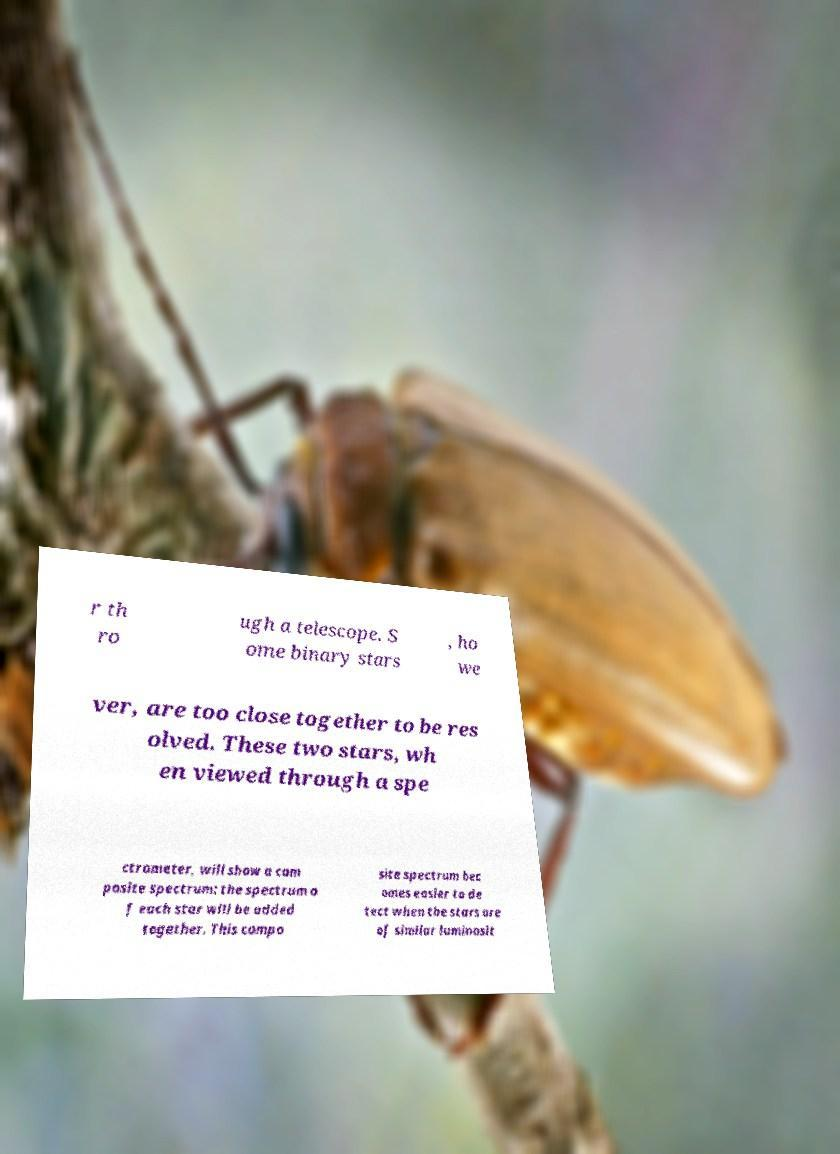There's text embedded in this image that I need extracted. Can you transcribe it verbatim? r th ro ugh a telescope. S ome binary stars , ho we ver, are too close together to be res olved. These two stars, wh en viewed through a spe ctrometer, will show a com posite spectrum: the spectrum o f each star will be added together. This compo site spectrum bec omes easier to de tect when the stars are of similar luminosit 